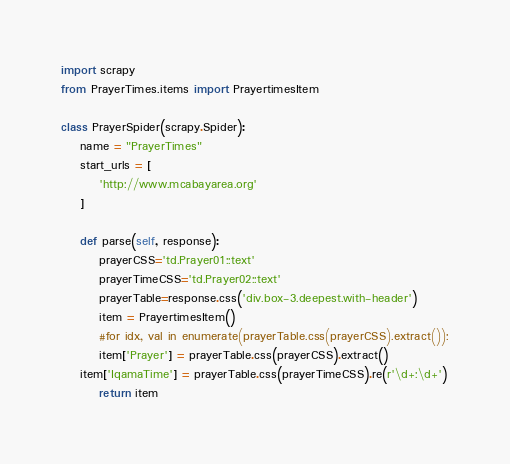Convert code to text. <code><loc_0><loc_0><loc_500><loc_500><_Python_>import scrapy
from PrayerTimes.items import PrayertimesItem

class PrayerSpider(scrapy.Spider):
    name = "PrayerTimes"
    start_urls = [
        'http://www.mcabayarea.org'
    ]

    def parse(self, response):
        prayerCSS='td.Prayer01::text'
        prayerTimeCSS='td.Prayer02::text'
        prayerTable=response.css('div.box-3.deepest.with-header')
        item = PrayertimesItem()
        #for idx, val in enumerate(prayerTable.css(prayerCSS).extract()):
        item['Prayer'] = prayerTable.css(prayerCSS).extract()
	item['IqamaTime'] = prayerTable.css(prayerTimeCSS).re(r'\d+:\d+')
        return item
</code> 